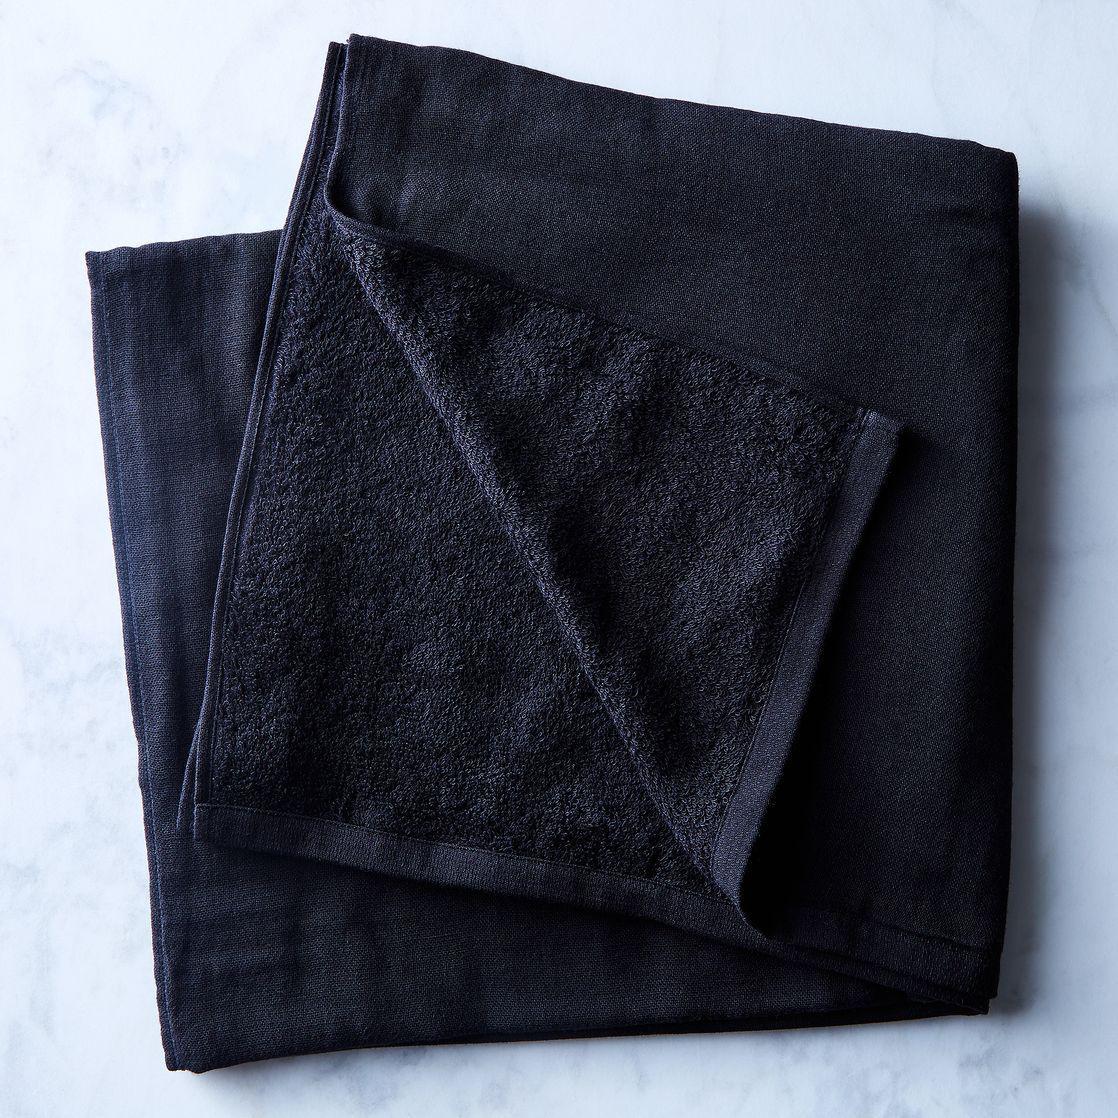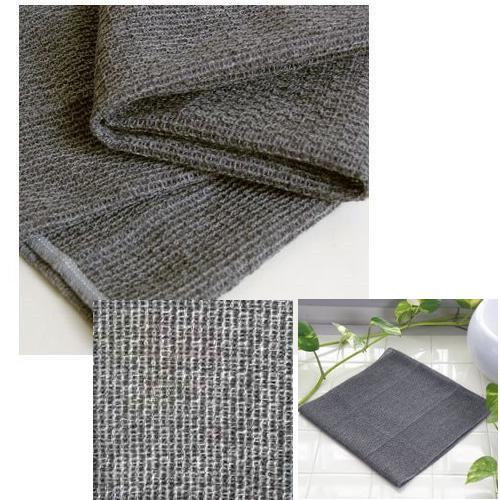The first image is the image on the left, the second image is the image on the right. Evaluate the accuracy of this statement regarding the images: "One of the images shows a folded gray item with a distinctive weave.". Is it true? Answer yes or no. Yes. 